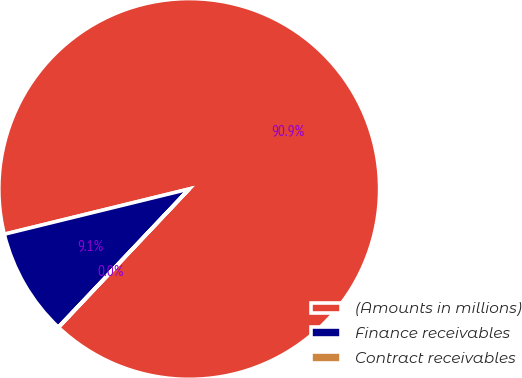<chart> <loc_0><loc_0><loc_500><loc_500><pie_chart><fcel>(Amounts in millions)<fcel>Finance receivables<fcel>Contract receivables<nl><fcel>90.85%<fcel>9.11%<fcel>0.03%<nl></chart> 